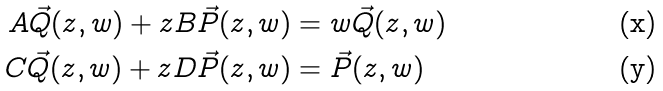Convert formula to latex. <formula><loc_0><loc_0><loc_500><loc_500>A \vec { Q } ( z , w ) + z B \vec { P } ( z , w ) & = w \vec { Q } ( z , w ) \\ C \vec { Q } ( z , w ) + z D \vec { P } ( z , w ) & = \vec { P } ( z , w )</formula> 